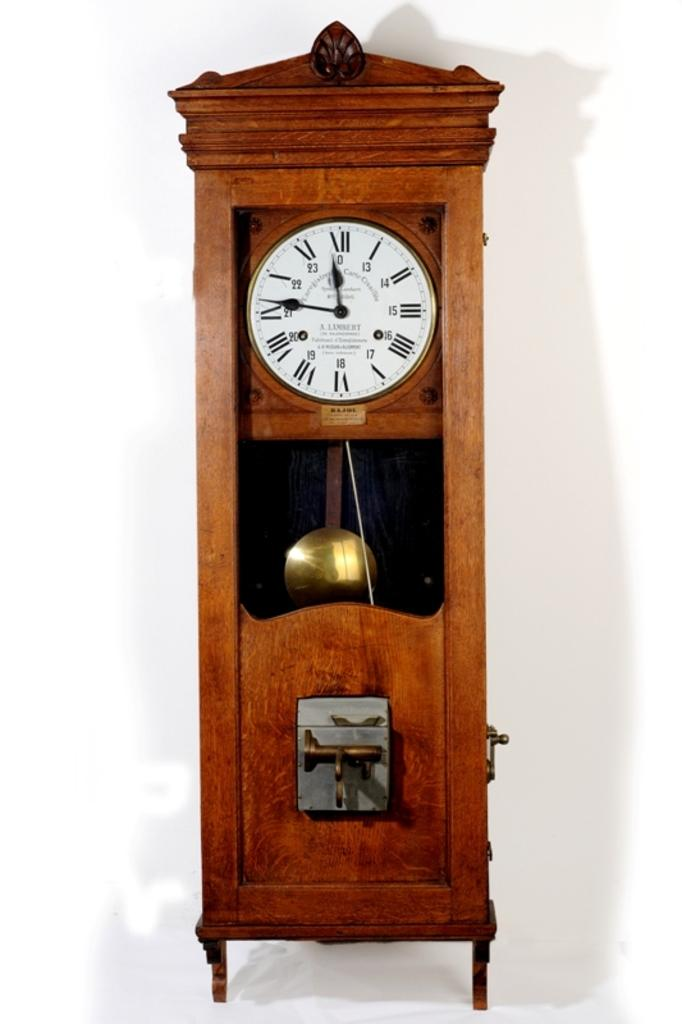<image>
Describe the image concisely. A clock with the time 11:46 on its face. 